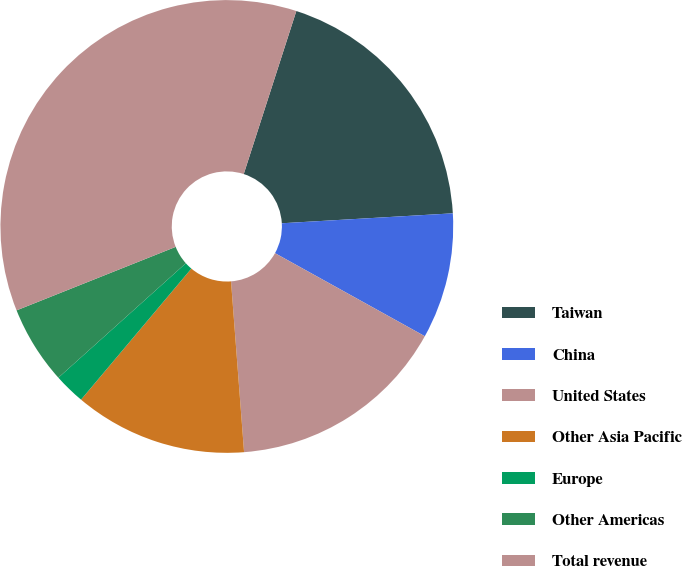Convert chart to OTSL. <chart><loc_0><loc_0><loc_500><loc_500><pie_chart><fcel>Taiwan<fcel>China<fcel>United States<fcel>Other Asia Pacific<fcel>Europe<fcel>Other Americas<fcel>Total revenue<nl><fcel>19.11%<fcel>8.98%<fcel>15.73%<fcel>12.35%<fcel>2.22%<fcel>5.6%<fcel>36.01%<nl></chart> 